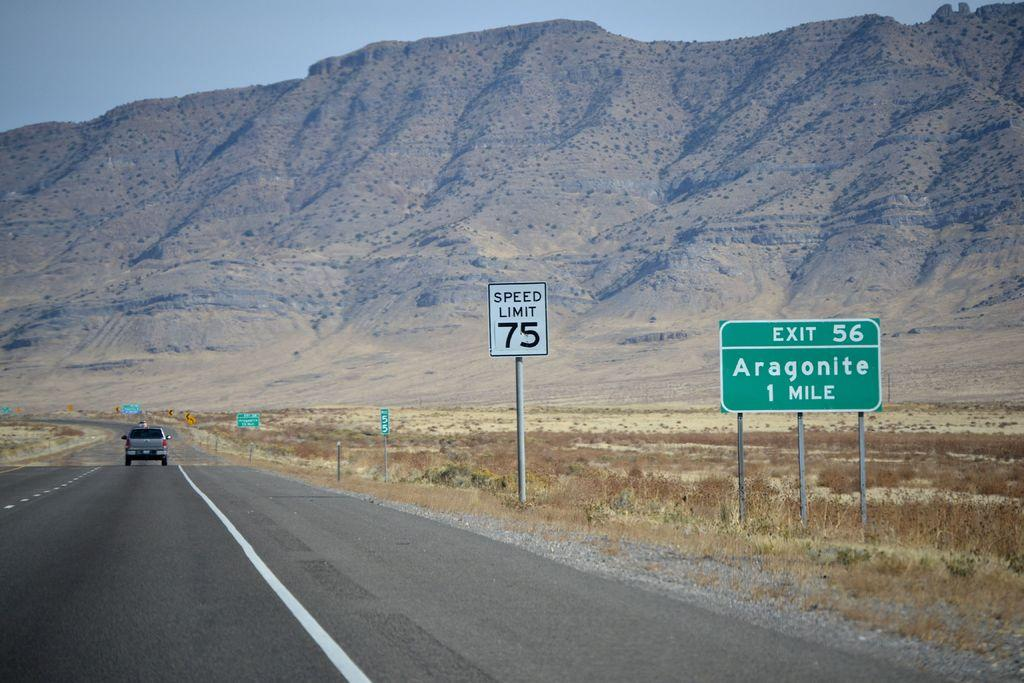<image>
Offer a succinct explanation of the picture presented. the speed limit of 75 is on the white sign 